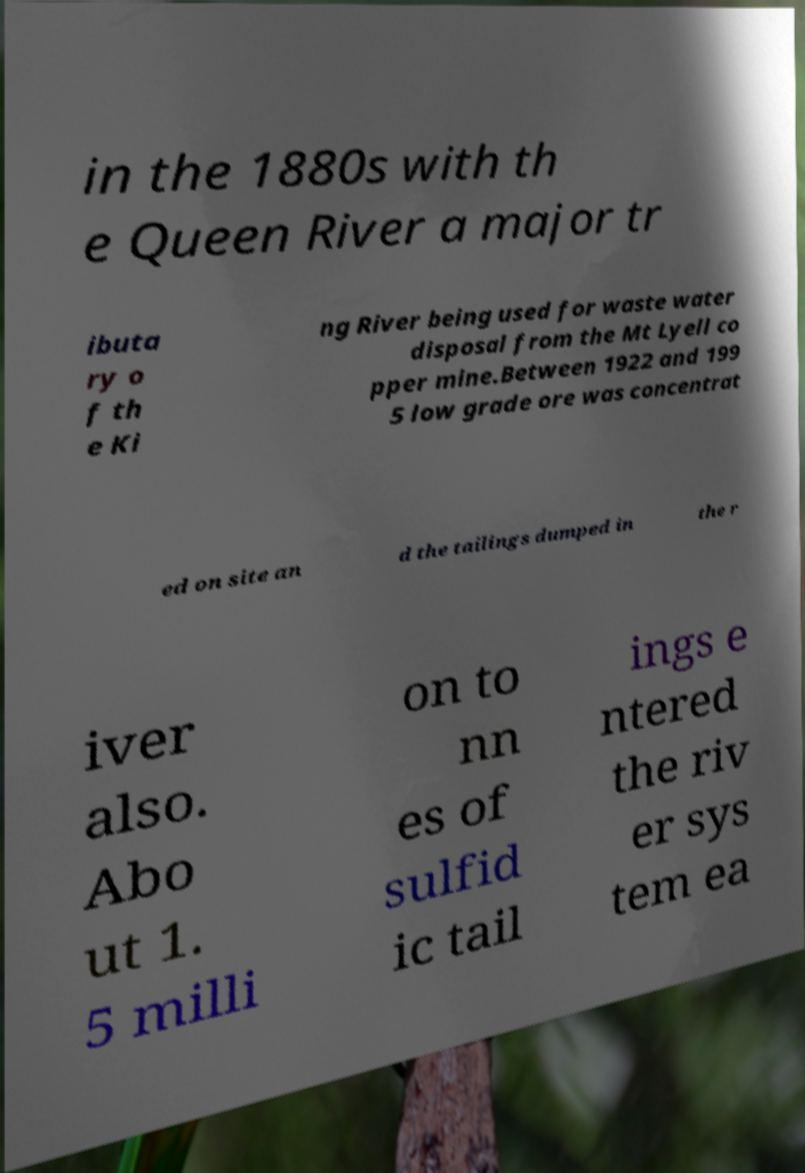Please read and relay the text visible in this image. What does it say? in the 1880s with th e Queen River a major tr ibuta ry o f th e Ki ng River being used for waste water disposal from the Mt Lyell co pper mine.Between 1922 and 199 5 low grade ore was concentrat ed on site an d the tailings dumped in the r iver also. Abo ut 1. 5 milli on to nn es of sulfid ic tail ings e ntered the riv er sys tem ea 